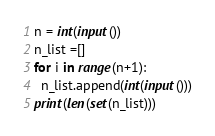Convert code to text. <code><loc_0><loc_0><loc_500><loc_500><_Python_>n = int(input())
n_list =[]
for i in range(n+1):
  n_list.append(int(input()))
print(len(set(n_list)))  
</code> 